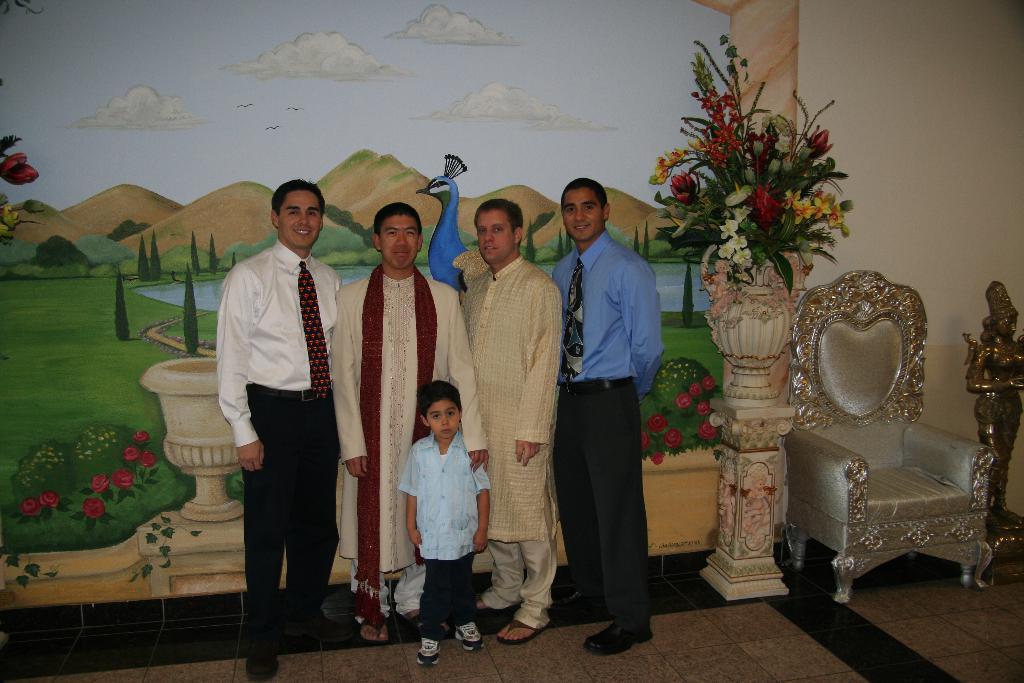Could you give a brief overview of what you see in this image? In this picture we can see some persons are standing on the floor. This is chair. On the background there is a wall and this is painting. And there is a flower vase. 